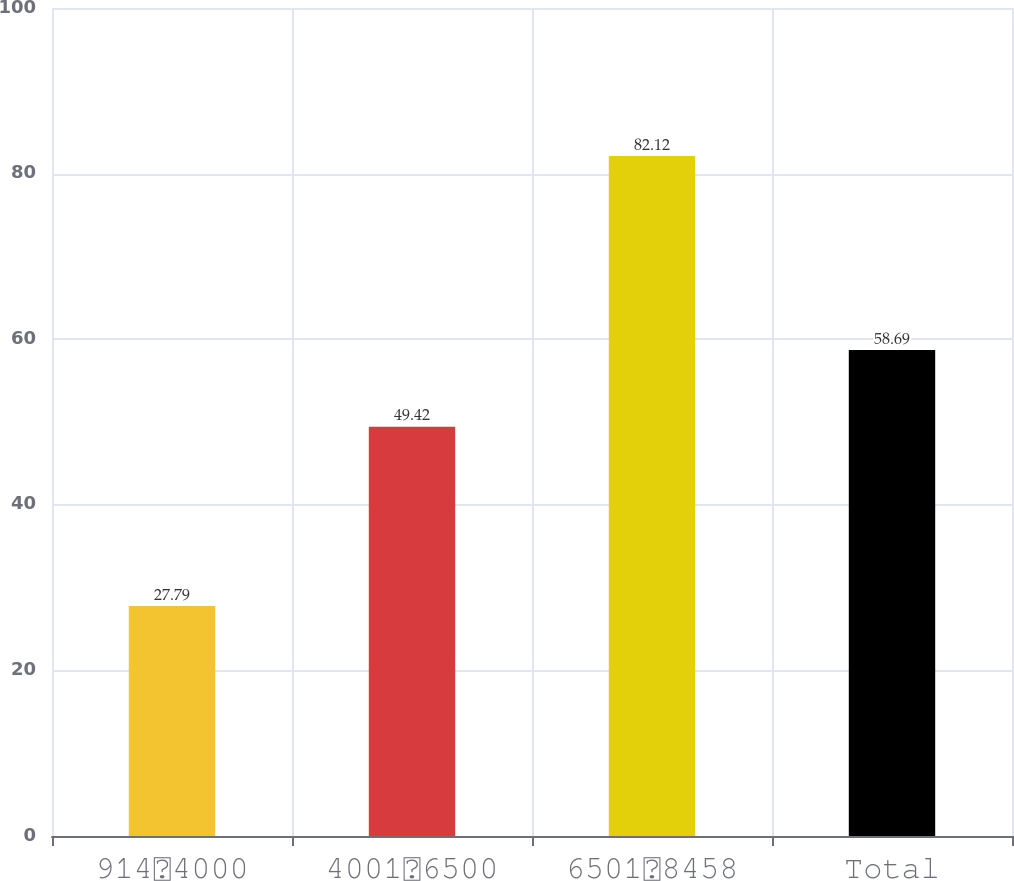Convert chart. <chart><loc_0><loc_0><loc_500><loc_500><bar_chart><fcel>9144000<fcel>40016500<fcel>65018458<fcel>Total<nl><fcel>27.79<fcel>49.42<fcel>82.12<fcel>58.69<nl></chart> 